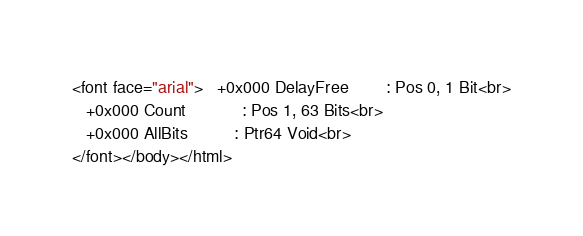<code> <loc_0><loc_0><loc_500><loc_500><_HTML_><font face="arial">   +0x000 DelayFree        : Pos 0, 1 Bit<br>
   +0x000 Count            : Pos 1, 63 Bits<br>
   +0x000 AllBits          : Ptr64 Void<br>
</font></body></html></code> 